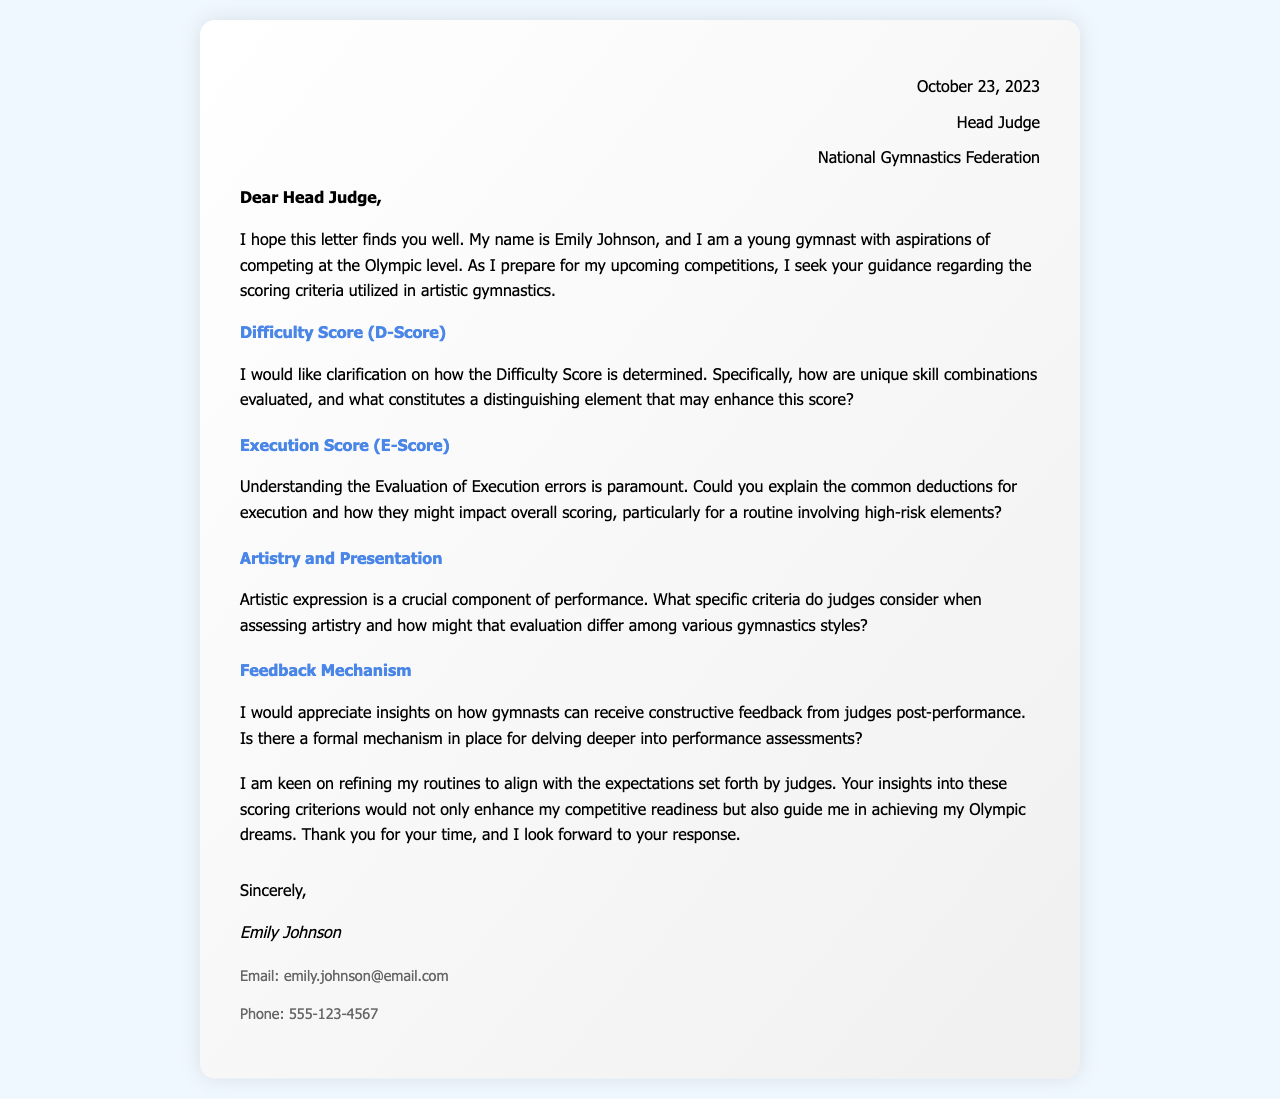What is the date of the letter? The letter is dated October 23, 2023, as indicated at the top of the document.
Answer: October 23, 2023 Who is the letter addressed to? The salutation of the letter specifies it is directed to the Head Judge.
Answer: Head Judge What is the name of the gymnast? The first paragraph of the letter introduces the gymnast as Emily Johnson.
Answer: Emily Johnson What is the primary purpose of the letter? The content outlines that the purpose is to seek clarification on scoring criteria in artistic gymnastics.
Answer: Seek clarification on scoring criteria What aspect of scoring does the gymnast inquire about in relation to unique skill combinations? The gymnast asks specifically about the Difficulty Score (D-Score).
Answer: Difficulty Score (D-Score) How does Emily Johnson hope to improve her routines? She hopes to refine her routines to align with the expectations set forth by judges.
Answer: Align with expectations What method does Emily Johnson want regarding feedback from judges? She seeks to understand if there is a formal mechanism for receiving constructive feedback post-performance.
Answer: Formal mechanism for feedback Which element of the scoring system involves execution errors? The Execution Score (E-Score) is the element that involves deductions for execution errors.
Answer: Execution Score (E-Score) What component is crucial in assessing a gymnast's performance according to the letter? Artistic expression is highlighted as a crucial component of performance evaluation.
Answer: Artistic expression 